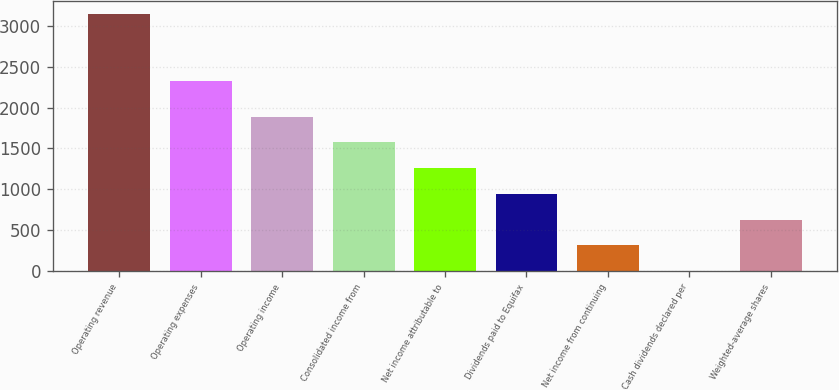Convert chart. <chart><loc_0><loc_0><loc_500><loc_500><bar_chart><fcel>Operating revenue<fcel>Operating expenses<fcel>Operating income<fcel>Consolidated income from<fcel>Net income attributable to<fcel>Dividends paid to Equifax<fcel>Net income from continuing<fcel>Cash dividends declared per<fcel>Weighted-average shares<nl><fcel>3144.9<fcel>2327<fcel>1887.48<fcel>1573.12<fcel>1258.76<fcel>944.4<fcel>315.68<fcel>1.32<fcel>630.04<nl></chart> 